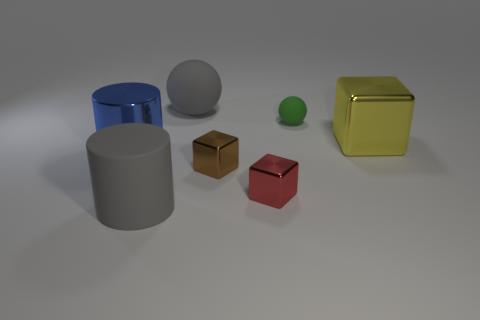Subtract all cyan balls. Subtract all brown cylinders. How many balls are left? 2 Add 2 green rubber objects. How many objects exist? 9 Subtract all blocks. How many objects are left? 4 Add 6 red blocks. How many red blocks are left? 7 Add 3 small brown metallic cubes. How many small brown metallic cubes exist? 4 Subtract 0 green cylinders. How many objects are left? 7 Subtract all large yellow objects. Subtract all tiny gray matte cylinders. How many objects are left? 6 